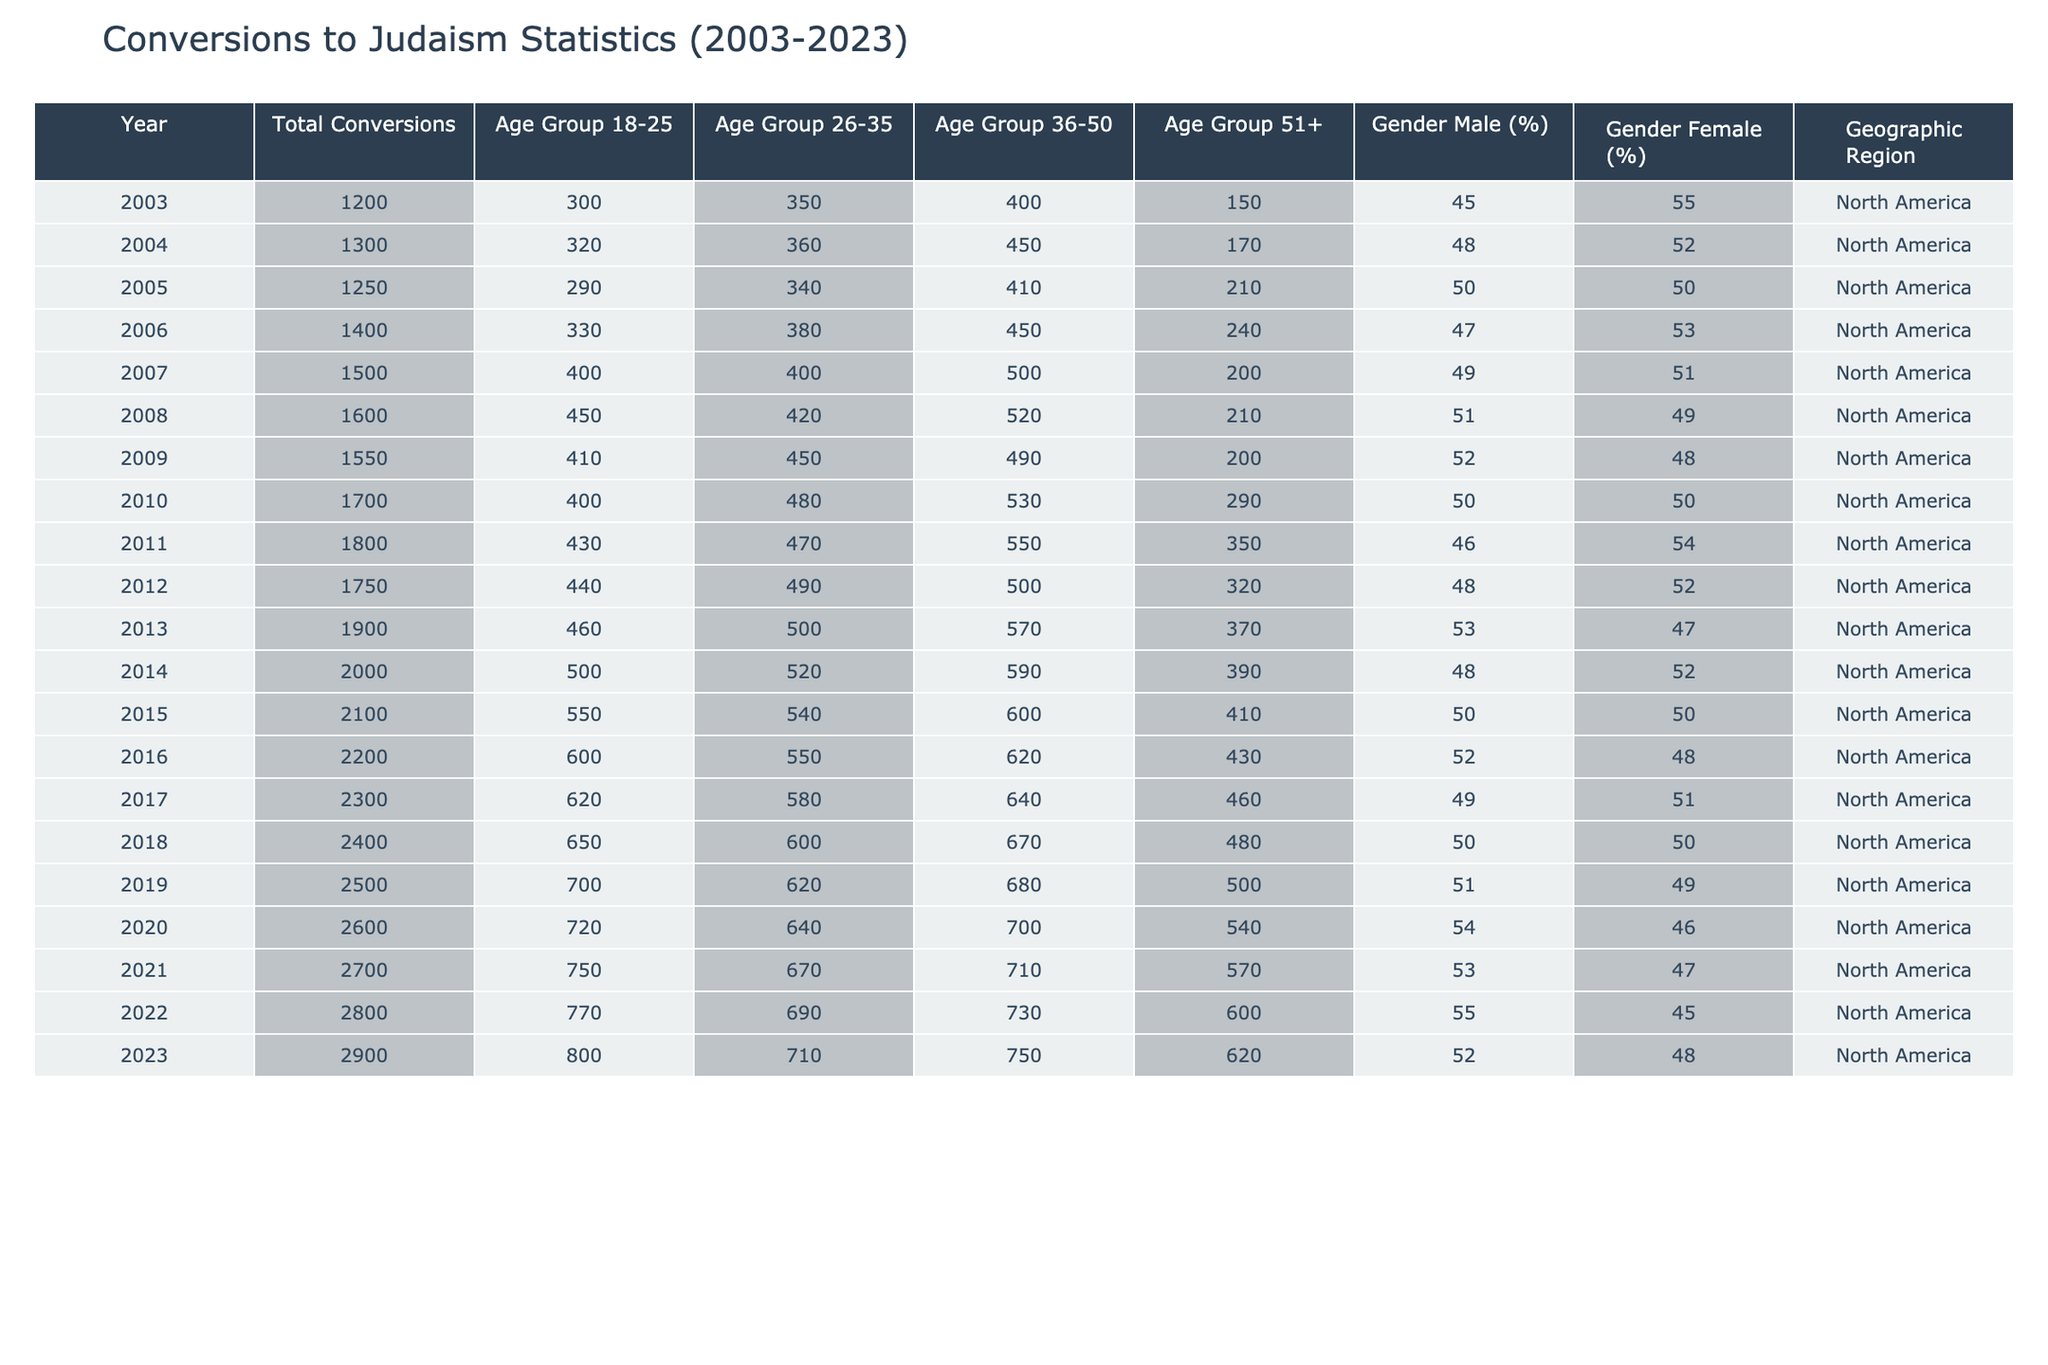What was the total number of conversions to Judaism in 2010? In the year 2010, the table shows that the total number of conversions to Judaism was 1700 as directly indicated in the 'Total Conversions' column for that year.
Answer: 1700 What percentage of total conversions were males in 2023? In 2023, the table indicates that the percentage of males among the total conversions was 52%, as shown in the 'Gender Male (%)' column for that year.
Answer: 52% Which age group had the highest number of conversions in 2018? For the year 2018, the age group 26-35 had 600 conversions, while all other age groups had fewer: 650 (18-25), 670 (36-50), and 480 (51+). Hence, the 26-35 age group had the highest number.
Answer: 26-35 What is the total number of conversions across all age groups for 2021? The total number of conversions for 2021 is obtained by summing the conversions from all age groups: 750 (18-25) + 670 (26-35) + 710 (36-50) + 570 (51+) = 2700. This total matches the 'Total Conversions' for that year.
Answer: 2700 Did the number of conversions to Judaism increase every year from 2003 to 2023? Observing the data from 2003 to 2023in the 'Total Conversions' column, we notice that the number of conversions increased each year, from 1200 in 2003 to 2900 in 2023 without any decreases. Thus, the statement is true.
Answer: Yes What is the average number of conversions for the age group 51+ over the 20-year period? To find the average for the 51+ age group, we sum the conversions over the 20 years: 150 + 170 + 210 + 240 + 200 + 210 + 200 + 290 + 350 + 320 + 370 + 390 + 410 + 430 + 460 + 480 + 500 + 540 + 570 + 620 = 8190. Dividing this by the 20 years gives us an average of 409.5.
Answer: 409.5 What was the highest number of conversions in any year during this period? By examining the 'Total Conversions' column, we see that the highest number recorded is 2900 in the year 2023, compared to all other years listed in the table.
Answer: 2900 In which year did the age group 36-50 have the most conversions? Analyzing the 'Age Group 36-50' column, the highest value recorded for conversions in that age group was 750 in the year 2023, which is greater than the values recorded in other years for that group.
Answer: 2023 How many conversions were recorded from the age group 18-25 in 2015? Referring to the age group 18-25 column for the year 2015, the recorded number of conversions was 550 as indicated in the table.
Answer: 550 